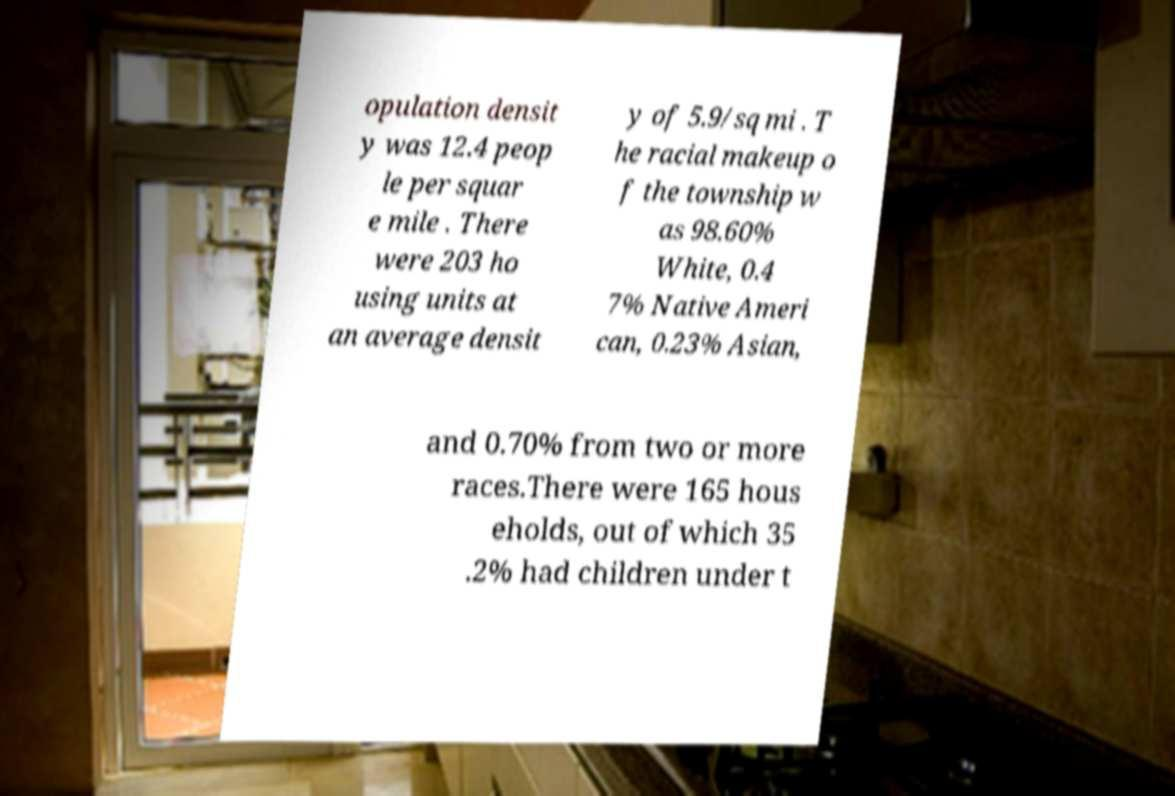There's text embedded in this image that I need extracted. Can you transcribe it verbatim? opulation densit y was 12.4 peop le per squar e mile . There were 203 ho using units at an average densit y of 5.9/sq mi . T he racial makeup o f the township w as 98.60% White, 0.4 7% Native Ameri can, 0.23% Asian, and 0.70% from two or more races.There were 165 hous eholds, out of which 35 .2% had children under t 